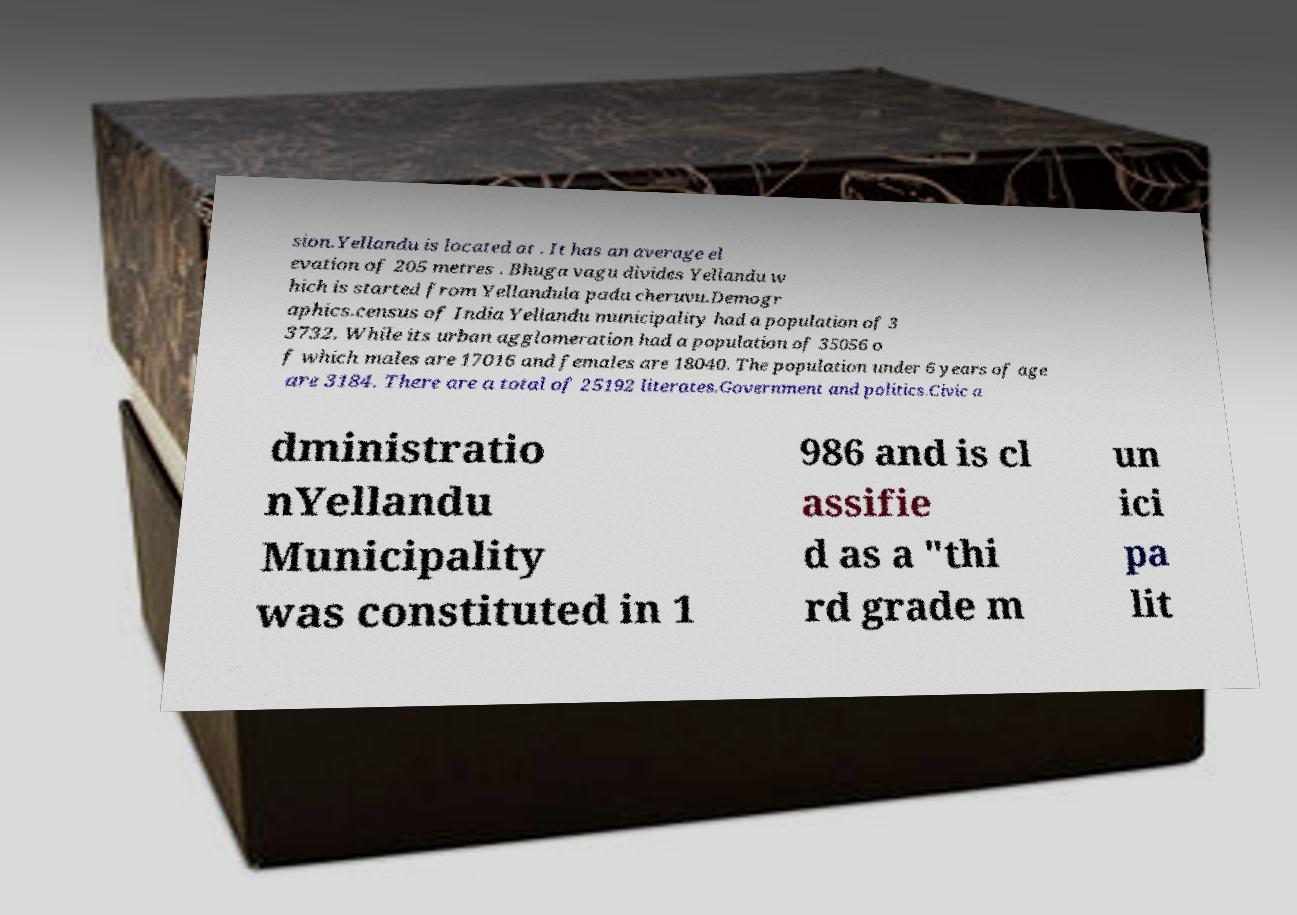What messages or text are displayed in this image? I need them in a readable, typed format. sion.Yellandu is located at . It has an average el evation of 205 metres . Bhuga vagu divides Yellandu w hich is started from Yellandula padu cheruvu.Demogr aphics.census of India Yellandu municipality had a population of 3 3732. While its urban agglomeration had a population of 35056 o f which males are 17016 and females are 18040. The population under 6 years of age are 3184. There are a total of 25192 literates.Government and politics.Civic a dministratio nYellandu Municipality was constituted in 1 986 and is cl assifie d as a "thi rd grade m un ici pa lit 